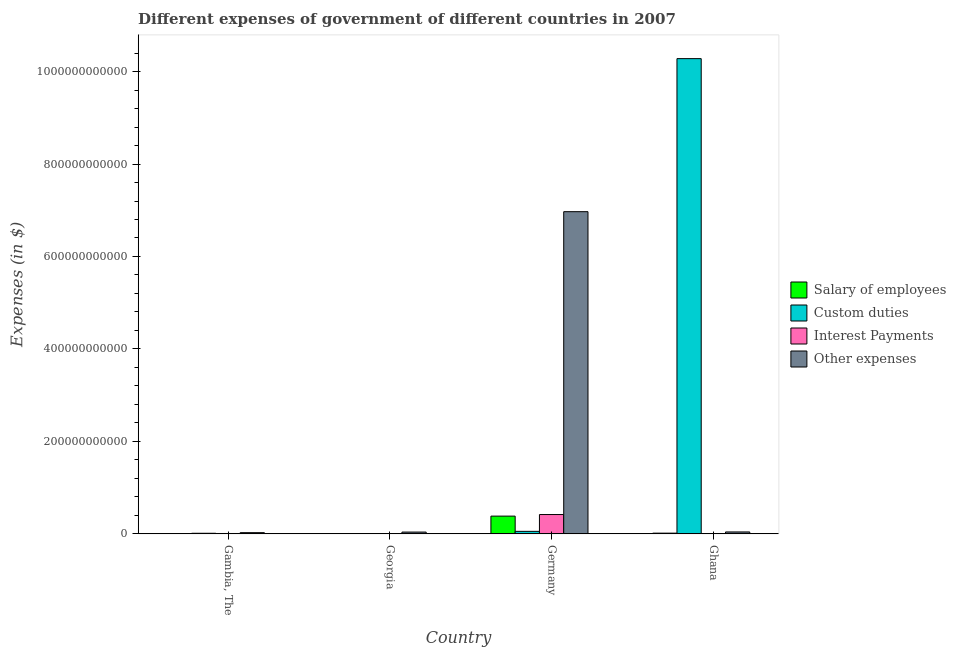How many different coloured bars are there?
Provide a short and direct response. 4. How many groups of bars are there?
Keep it short and to the point. 4. Are the number of bars per tick equal to the number of legend labels?
Your answer should be very brief. No. How many bars are there on the 3rd tick from the right?
Your answer should be very brief. 3. What is the label of the 3rd group of bars from the left?
Make the answer very short. Germany. What is the amount spent on custom duties in Germany?
Keep it short and to the point. 5.45e+09. Across all countries, what is the maximum amount spent on salary of employees?
Provide a succinct answer. 3.84e+1. Across all countries, what is the minimum amount spent on salary of employees?
Ensure brevity in your answer.  6.04e+08. In which country was the amount spent on other expenses maximum?
Ensure brevity in your answer.  Germany. What is the total amount spent on other expenses in the graph?
Your answer should be very brief. 7.08e+11. What is the difference between the amount spent on interest payments in Georgia and that in Germany?
Give a very brief answer. -4.17e+1. What is the difference between the amount spent on salary of employees in Ghana and the amount spent on other expenses in Georgia?
Offer a terse response. -2.34e+09. What is the average amount spent on interest payments per country?
Give a very brief answer. 1.08e+1. What is the difference between the amount spent on salary of employees and amount spent on interest payments in Germany?
Offer a terse response. -3.42e+09. In how many countries, is the amount spent on interest payments greater than 480000000000 $?
Ensure brevity in your answer.  0. What is the ratio of the amount spent on other expenses in Georgia to that in Germany?
Your response must be concise. 0.01. Is the amount spent on salary of employees in Gambia, The less than that in Germany?
Your response must be concise. Yes. What is the difference between the highest and the second highest amount spent on custom duties?
Keep it short and to the point. 1.02e+12. What is the difference between the highest and the lowest amount spent on interest payments?
Give a very brief answer. 4.17e+1. In how many countries, is the amount spent on interest payments greater than the average amount spent on interest payments taken over all countries?
Ensure brevity in your answer.  1. Is it the case that in every country, the sum of the amount spent on custom duties and amount spent on interest payments is greater than the sum of amount spent on salary of employees and amount spent on other expenses?
Your answer should be very brief. No. Are all the bars in the graph horizontal?
Ensure brevity in your answer.  No. How many countries are there in the graph?
Ensure brevity in your answer.  4. What is the difference between two consecutive major ticks on the Y-axis?
Provide a succinct answer. 2.00e+11. How are the legend labels stacked?
Offer a terse response. Vertical. What is the title of the graph?
Offer a terse response. Different expenses of government of different countries in 2007. Does "Tracking ability" appear as one of the legend labels in the graph?
Ensure brevity in your answer.  No. What is the label or title of the Y-axis?
Provide a succinct answer. Expenses (in $). What is the Expenses (in $) of Salary of employees in Gambia, The?
Provide a succinct answer. 6.80e+08. What is the Expenses (in $) of Custom duties in Gambia, The?
Offer a terse response. 1.28e+09. What is the Expenses (in $) in Interest Payments in Gambia, The?
Give a very brief answer. 8.15e+08. What is the Expenses (in $) of Other expenses in Gambia, The?
Your answer should be very brief. 2.58e+09. What is the Expenses (in $) in Salary of employees in Georgia?
Offer a very short reply. 6.04e+08. What is the Expenses (in $) of Custom duties in Georgia?
Your answer should be very brief. 0. What is the Expenses (in $) of Interest Payments in Georgia?
Offer a very short reply. 9.74e+07. What is the Expenses (in $) of Other expenses in Georgia?
Keep it short and to the point. 3.89e+09. What is the Expenses (in $) in Salary of employees in Germany?
Provide a short and direct response. 3.84e+1. What is the Expenses (in $) in Custom duties in Germany?
Provide a short and direct response. 5.45e+09. What is the Expenses (in $) of Interest Payments in Germany?
Offer a very short reply. 4.18e+1. What is the Expenses (in $) in Other expenses in Germany?
Offer a very short reply. 6.97e+11. What is the Expenses (in $) in Salary of employees in Ghana?
Provide a short and direct response. 1.55e+09. What is the Expenses (in $) of Custom duties in Ghana?
Give a very brief answer. 1.03e+12. What is the Expenses (in $) of Interest Payments in Ghana?
Offer a very short reply. 4.40e+08. What is the Expenses (in $) of Other expenses in Ghana?
Provide a succinct answer. 4.14e+09. Across all countries, what is the maximum Expenses (in $) of Salary of employees?
Your answer should be very brief. 3.84e+1. Across all countries, what is the maximum Expenses (in $) in Custom duties?
Your answer should be very brief. 1.03e+12. Across all countries, what is the maximum Expenses (in $) of Interest Payments?
Provide a short and direct response. 4.18e+1. Across all countries, what is the maximum Expenses (in $) in Other expenses?
Give a very brief answer. 6.97e+11. Across all countries, what is the minimum Expenses (in $) in Salary of employees?
Provide a succinct answer. 6.04e+08. Across all countries, what is the minimum Expenses (in $) in Interest Payments?
Your answer should be very brief. 9.74e+07. Across all countries, what is the minimum Expenses (in $) of Other expenses?
Offer a very short reply. 2.58e+09. What is the total Expenses (in $) of Salary of employees in the graph?
Your answer should be compact. 4.12e+1. What is the total Expenses (in $) in Custom duties in the graph?
Provide a succinct answer. 1.03e+12. What is the total Expenses (in $) in Interest Payments in the graph?
Your response must be concise. 4.32e+1. What is the total Expenses (in $) in Other expenses in the graph?
Make the answer very short. 7.08e+11. What is the difference between the Expenses (in $) of Salary of employees in Gambia, The and that in Georgia?
Your answer should be compact. 7.69e+07. What is the difference between the Expenses (in $) of Interest Payments in Gambia, The and that in Georgia?
Your answer should be very brief. 7.18e+08. What is the difference between the Expenses (in $) in Other expenses in Gambia, The and that in Georgia?
Make the answer very short. -1.31e+09. What is the difference between the Expenses (in $) in Salary of employees in Gambia, The and that in Germany?
Offer a terse response. -3.77e+1. What is the difference between the Expenses (in $) of Custom duties in Gambia, The and that in Germany?
Ensure brevity in your answer.  -4.17e+09. What is the difference between the Expenses (in $) of Interest Payments in Gambia, The and that in Germany?
Your answer should be very brief. -4.10e+1. What is the difference between the Expenses (in $) in Other expenses in Gambia, The and that in Germany?
Your answer should be very brief. -6.94e+11. What is the difference between the Expenses (in $) in Salary of employees in Gambia, The and that in Ghana?
Provide a succinct answer. -8.71e+08. What is the difference between the Expenses (in $) of Custom duties in Gambia, The and that in Ghana?
Make the answer very short. -1.03e+12. What is the difference between the Expenses (in $) of Interest Payments in Gambia, The and that in Ghana?
Provide a succinct answer. 3.75e+08. What is the difference between the Expenses (in $) of Other expenses in Gambia, The and that in Ghana?
Your answer should be compact. -1.55e+09. What is the difference between the Expenses (in $) of Salary of employees in Georgia and that in Germany?
Give a very brief answer. -3.78e+1. What is the difference between the Expenses (in $) in Interest Payments in Georgia and that in Germany?
Your answer should be compact. -4.17e+1. What is the difference between the Expenses (in $) in Other expenses in Georgia and that in Germany?
Make the answer very short. -6.93e+11. What is the difference between the Expenses (in $) of Salary of employees in Georgia and that in Ghana?
Provide a short and direct response. -9.48e+08. What is the difference between the Expenses (in $) of Interest Payments in Georgia and that in Ghana?
Your response must be concise. -3.43e+08. What is the difference between the Expenses (in $) in Other expenses in Georgia and that in Ghana?
Make the answer very short. -2.47e+08. What is the difference between the Expenses (in $) of Salary of employees in Germany and that in Ghana?
Provide a short and direct response. 3.68e+1. What is the difference between the Expenses (in $) in Custom duties in Germany and that in Ghana?
Provide a short and direct response. -1.02e+12. What is the difference between the Expenses (in $) in Interest Payments in Germany and that in Ghana?
Offer a very short reply. 4.14e+1. What is the difference between the Expenses (in $) of Other expenses in Germany and that in Ghana?
Your answer should be compact. 6.93e+11. What is the difference between the Expenses (in $) in Salary of employees in Gambia, The and the Expenses (in $) in Interest Payments in Georgia?
Offer a very short reply. 5.83e+08. What is the difference between the Expenses (in $) in Salary of employees in Gambia, The and the Expenses (in $) in Other expenses in Georgia?
Give a very brief answer. -3.21e+09. What is the difference between the Expenses (in $) in Custom duties in Gambia, The and the Expenses (in $) in Interest Payments in Georgia?
Provide a succinct answer. 1.18e+09. What is the difference between the Expenses (in $) in Custom duties in Gambia, The and the Expenses (in $) in Other expenses in Georgia?
Make the answer very short. -2.61e+09. What is the difference between the Expenses (in $) of Interest Payments in Gambia, The and the Expenses (in $) of Other expenses in Georgia?
Your answer should be very brief. -3.08e+09. What is the difference between the Expenses (in $) of Salary of employees in Gambia, The and the Expenses (in $) of Custom duties in Germany?
Your answer should be compact. -4.77e+09. What is the difference between the Expenses (in $) of Salary of employees in Gambia, The and the Expenses (in $) of Interest Payments in Germany?
Offer a terse response. -4.11e+1. What is the difference between the Expenses (in $) in Salary of employees in Gambia, The and the Expenses (in $) in Other expenses in Germany?
Your response must be concise. -6.96e+11. What is the difference between the Expenses (in $) of Custom duties in Gambia, The and the Expenses (in $) of Interest Payments in Germany?
Provide a succinct answer. -4.05e+1. What is the difference between the Expenses (in $) of Custom duties in Gambia, The and the Expenses (in $) of Other expenses in Germany?
Offer a terse response. -6.96e+11. What is the difference between the Expenses (in $) of Interest Payments in Gambia, The and the Expenses (in $) of Other expenses in Germany?
Offer a terse response. -6.96e+11. What is the difference between the Expenses (in $) of Salary of employees in Gambia, The and the Expenses (in $) of Custom duties in Ghana?
Offer a terse response. -1.03e+12. What is the difference between the Expenses (in $) in Salary of employees in Gambia, The and the Expenses (in $) in Interest Payments in Ghana?
Make the answer very short. 2.40e+08. What is the difference between the Expenses (in $) in Salary of employees in Gambia, The and the Expenses (in $) in Other expenses in Ghana?
Provide a short and direct response. -3.46e+09. What is the difference between the Expenses (in $) in Custom duties in Gambia, The and the Expenses (in $) in Interest Payments in Ghana?
Keep it short and to the point. 8.39e+08. What is the difference between the Expenses (in $) in Custom duties in Gambia, The and the Expenses (in $) in Other expenses in Ghana?
Provide a succinct answer. -2.86e+09. What is the difference between the Expenses (in $) of Interest Payments in Gambia, The and the Expenses (in $) of Other expenses in Ghana?
Ensure brevity in your answer.  -3.32e+09. What is the difference between the Expenses (in $) of Salary of employees in Georgia and the Expenses (in $) of Custom duties in Germany?
Offer a terse response. -4.84e+09. What is the difference between the Expenses (in $) in Salary of employees in Georgia and the Expenses (in $) in Interest Payments in Germany?
Your response must be concise. -4.12e+1. What is the difference between the Expenses (in $) of Salary of employees in Georgia and the Expenses (in $) of Other expenses in Germany?
Your answer should be very brief. -6.96e+11. What is the difference between the Expenses (in $) in Interest Payments in Georgia and the Expenses (in $) in Other expenses in Germany?
Provide a short and direct response. -6.97e+11. What is the difference between the Expenses (in $) in Salary of employees in Georgia and the Expenses (in $) in Custom duties in Ghana?
Your answer should be very brief. -1.03e+12. What is the difference between the Expenses (in $) of Salary of employees in Georgia and the Expenses (in $) of Interest Payments in Ghana?
Ensure brevity in your answer.  1.63e+08. What is the difference between the Expenses (in $) of Salary of employees in Georgia and the Expenses (in $) of Other expenses in Ghana?
Provide a short and direct response. -3.53e+09. What is the difference between the Expenses (in $) in Interest Payments in Georgia and the Expenses (in $) in Other expenses in Ghana?
Provide a succinct answer. -4.04e+09. What is the difference between the Expenses (in $) of Salary of employees in Germany and the Expenses (in $) of Custom duties in Ghana?
Give a very brief answer. -9.90e+11. What is the difference between the Expenses (in $) of Salary of employees in Germany and the Expenses (in $) of Interest Payments in Ghana?
Your response must be concise. 3.79e+1. What is the difference between the Expenses (in $) in Salary of employees in Germany and the Expenses (in $) in Other expenses in Ghana?
Offer a very short reply. 3.42e+1. What is the difference between the Expenses (in $) in Custom duties in Germany and the Expenses (in $) in Interest Payments in Ghana?
Offer a very short reply. 5.01e+09. What is the difference between the Expenses (in $) in Custom duties in Germany and the Expenses (in $) in Other expenses in Ghana?
Your answer should be compact. 1.31e+09. What is the difference between the Expenses (in $) of Interest Payments in Germany and the Expenses (in $) of Other expenses in Ghana?
Offer a terse response. 3.77e+1. What is the average Expenses (in $) of Salary of employees per country?
Provide a succinct answer. 1.03e+1. What is the average Expenses (in $) of Custom duties per country?
Your response must be concise. 2.59e+11. What is the average Expenses (in $) of Interest Payments per country?
Provide a succinct answer. 1.08e+1. What is the average Expenses (in $) in Other expenses per country?
Give a very brief answer. 1.77e+11. What is the difference between the Expenses (in $) in Salary of employees and Expenses (in $) in Custom duties in Gambia, The?
Keep it short and to the point. -5.99e+08. What is the difference between the Expenses (in $) of Salary of employees and Expenses (in $) of Interest Payments in Gambia, The?
Make the answer very short. -1.35e+08. What is the difference between the Expenses (in $) in Salary of employees and Expenses (in $) in Other expenses in Gambia, The?
Give a very brief answer. -1.90e+09. What is the difference between the Expenses (in $) in Custom duties and Expenses (in $) in Interest Payments in Gambia, The?
Your answer should be compact. 4.64e+08. What is the difference between the Expenses (in $) in Custom duties and Expenses (in $) in Other expenses in Gambia, The?
Offer a very short reply. -1.31e+09. What is the difference between the Expenses (in $) in Interest Payments and Expenses (in $) in Other expenses in Gambia, The?
Give a very brief answer. -1.77e+09. What is the difference between the Expenses (in $) of Salary of employees and Expenses (in $) of Interest Payments in Georgia?
Give a very brief answer. 5.06e+08. What is the difference between the Expenses (in $) in Salary of employees and Expenses (in $) in Other expenses in Georgia?
Offer a very short reply. -3.29e+09. What is the difference between the Expenses (in $) in Interest Payments and Expenses (in $) in Other expenses in Georgia?
Your answer should be compact. -3.79e+09. What is the difference between the Expenses (in $) of Salary of employees and Expenses (in $) of Custom duties in Germany?
Ensure brevity in your answer.  3.29e+1. What is the difference between the Expenses (in $) in Salary of employees and Expenses (in $) in Interest Payments in Germany?
Keep it short and to the point. -3.42e+09. What is the difference between the Expenses (in $) in Salary of employees and Expenses (in $) in Other expenses in Germany?
Keep it short and to the point. -6.59e+11. What is the difference between the Expenses (in $) of Custom duties and Expenses (in $) of Interest Payments in Germany?
Give a very brief answer. -3.64e+1. What is the difference between the Expenses (in $) of Custom duties and Expenses (in $) of Other expenses in Germany?
Offer a very short reply. -6.91e+11. What is the difference between the Expenses (in $) in Interest Payments and Expenses (in $) in Other expenses in Germany?
Your answer should be compact. -6.55e+11. What is the difference between the Expenses (in $) in Salary of employees and Expenses (in $) in Custom duties in Ghana?
Offer a terse response. -1.03e+12. What is the difference between the Expenses (in $) of Salary of employees and Expenses (in $) of Interest Payments in Ghana?
Your response must be concise. 1.11e+09. What is the difference between the Expenses (in $) of Salary of employees and Expenses (in $) of Other expenses in Ghana?
Offer a very short reply. -2.58e+09. What is the difference between the Expenses (in $) in Custom duties and Expenses (in $) in Interest Payments in Ghana?
Offer a very short reply. 1.03e+12. What is the difference between the Expenses (in $) of Custom duties and Expenses (in $) of Other expenses in Ghana?
Offer a very short reply. 1.02e+12. What is the difference between the Expenses (in $) in Interest Payments and Expenses (in $) in Other expenses in Ghana?
Your answer should be compact. -3.70e+09. What is the ratio of the Expenses (in $) in Salary of employees in Gambia, The to that in Georgia?
Provide a short and direct response. 1.13. What is the ratio of the Expenses (in $) of Interest Payments in Gambia, The to that in Georgia?
Your response must be concise. 8.37. What is the ratio of the Expenses (in $) of Other expenses in Gambia, The to that in Georgia?
Make the answer very short. 0.66. What is the ratio of the Expenses (in $) in Salary of employees in Gambia, The to that in Germany?
Your answer should be compact. 0.02. What is the ratio of the Expenses (in $) of Custom duties in Gambia, The to that in Germany?
Give a very brief answer. 0.23. What is the ratio of the Expenses (in $) of Interest Payments in Gambia, The to that in Germany?
Give a very brief answer. 0.02. What is the ratio of the Expenses (in $) of Other expenses in Gambia, The to that in Germany?
Your response must be concise. 0. What is the ratio of the Expenses (in $) of Salary of employees in Gambia, The to that in Ghana?
Ensure brevity in your answer.  0.44. What is the ratio of the Expenses (in $) of Custom duties in Gambia, The to that in Ghana?
Your response must be concise. 0. What is the ratio of the Expenses (in $) in Interest Payments in Gambia, The to that in Ghana?
Give a very brief answer. 1.85. What is the ratio of the Expenses (in $) in Other expenses in Gambia, The to that in Ghana?
Make the answer very short. 0.62. What is the ratio of the Expenses (in $) of Salary of employees in Georgia to that in Germany?
Provide a short and direct response. 0.02. What is the ratio of the Expenses (in $) in Interest Payments in Georgia to that in Germany?
Keep it short and to the point. 0. What is the ratio of the Expenses (in $) of Other expenses in Georgia to that in Germany?
Offer a very short reply. 0.01. What is the ratio of the Expenses (in $) in Salary of employees in Georgia to that in Ghana?
Offer a very short reply. 0.39. What is the ratio of the Expenses (in $) in Interest Payments in Georgia to that in Ghana?
Ensure brevity in your answer.  0.22. What is the ratio of the Expenses (in $) of Other expenses in Georgia to that in Ghana?
Offer a terse response. 0.94. What is the ratio of the Expenses (in $) in Salary of employees in Germany to that in Ghana?
Provide a short and direct response. 24.73. What is the ratio of the Expenses (in $) of Custom duties in Germany to that in Ghana?
Offer a terse response. 0.01. What is the ratio of the Expenses (in $) of Interest Payments in Germany to that in Ghana?
Your answer should be very brief. 95. What is the ratio of the Expenses (in $) of Other expenses in Germany to that in Ghana?
Offer a terse response. 168.48. What is the difference between the highest and the second highest Expenses (in $) in Salary of employees?
Give a very brief answer. 3.68e+1. What is the difference between the highest and the second highest Expenses (in $) of Custom duties?
Offer a terse response. 1.02e+12. What is the difference between the highest and the second highest Expenses (in $) of Interest Payments?
Provide a short and direct response. 4.10e+1. What is the difference between the highest and the second highest Expenses (in $) of Other expenses?
Give a very brief answer. 6.93e+11. What is the difference between the highest and the lowest Expenses (in $) in Salary of employees?
Make the answer very short. 3.78e+1. What is the difference between the highest and the lowest Expenses (in $) in Custom duties?
Offer a very short reply. 1.03e+12. What is the difference between the highest and the lowest Expenses (in $) of Interest Payments?
Your answer should be compact. 4.17e+1. What is the difference between the highest and the lowest Expenses (in $) in Other expenses?
Offer a very short reply. 6.94e+11. 